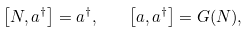<formula> <loc_0><loc_0><loc_500><loc_500>\left [ N , a ^ { \dagger } \right ] = a ^ { \dagger } , \quad \left [ a , a ^ { \dagger } \right ] = G ( N ) ,</formula> 